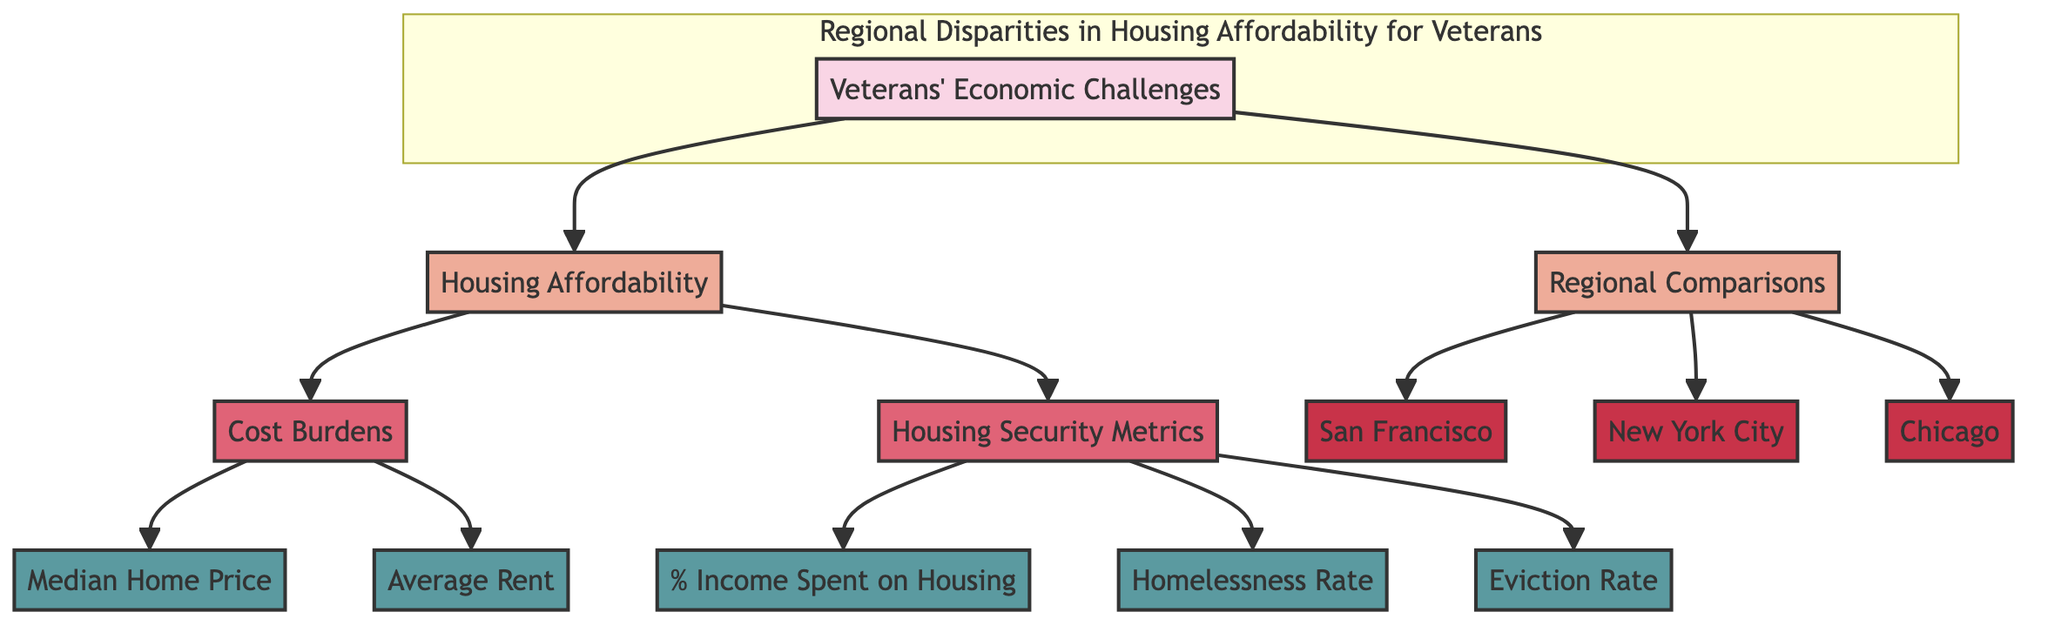What are the two main topics addressed in the diagram? The diagram highlights two main topics: "Housing Affordability" and "Regional Comparisons." These are directly connected to the central theme of veterans' economic challenges.
Answer: Housing Affordability, Regional Comparisons Which city is listed first in the "Regional Comparisons" section? In the diagram, "San Francisco" is the first city listed under the "Regional Comparisons" section, indicating the order in which they are presented.
Answer: San Francisco What metric is associated with "Cost Burdens"? Under the "Cost Burdens" category, both "Median Home Price" and "Average Rent" are listed as key metrics impacting housing affordability for veterans. This means either of these metrics could be the answer.
Answer: Median Home Price, Average Rent Which metric reflects the percentage of income spent on housing? The metric that specifically addresses the financial burden on veterans is "% Income Spent on Housing," which highlights affordability concerns directly.
Answer: % Income Spent on Housing How many cities are compared in the diagram? The diagram compares three cities: San Francisco, New York City, and Chicago, reflecting the broader regional disparities in housing affordability for veterans.
Answer: Three Which housing security metric is likely to be the most critical indicator of housing insecurity among veterans? The "Homelessness Rate" is often seen as a critical indicator of housing insecurity, suggesting how many veterans are affected by the lack of stable housing compared to the other metrics.
Answer: Homelessness Rate Is "Eviction Rate" part of the "Housing Security Metrics"? Yes, "Eviction Rate" falls under the "Housing Security Metrics" section, indicating it is a crucial measure for understanding housing stability among veterans.
Answer: Yes What connections exist between "Housing Affordability" and "Regional Comparisons"? "Housing Affordability" and "Regional Comparisons" are both connected to veterans' economic challenges; they illustrate the situation veterans face in different regions regarding housing.
Answer: Both connected to veterans' economic challenges 